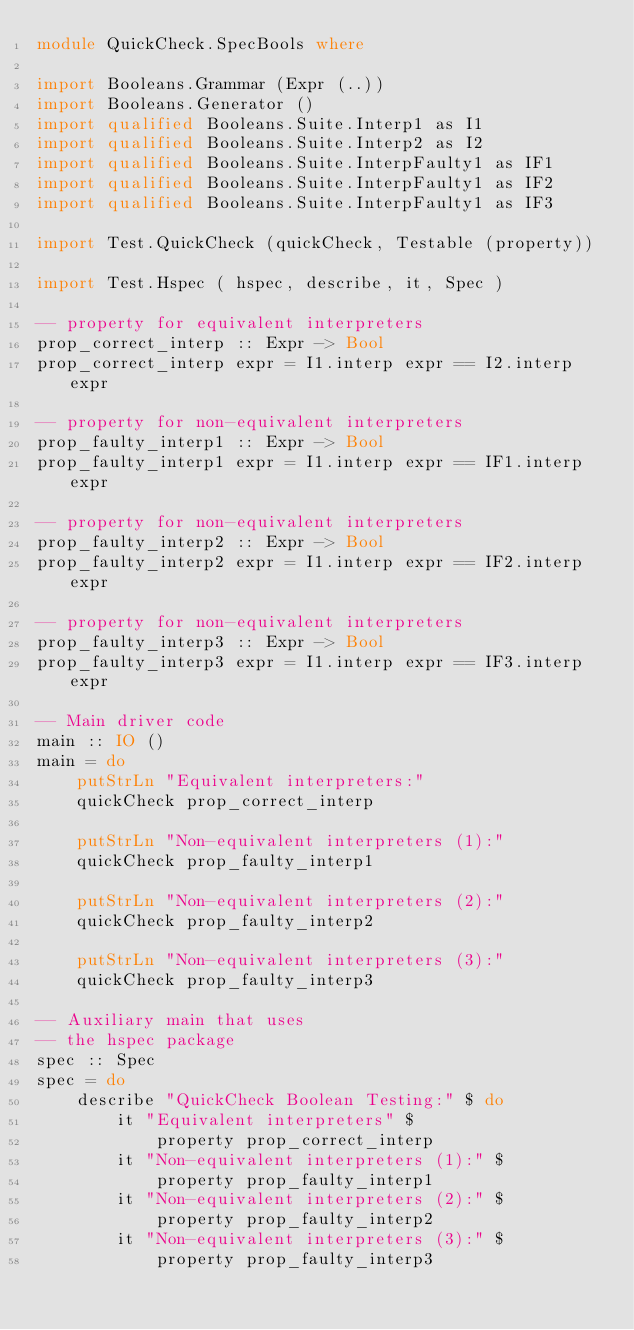<code> <loc_0><loc_0><loc_500><loc_500><_Haskell_>module QuickCheck.SpecBools where

import Booleans.Grammar (Expr (..))
import Booleans.Generator ()
import qualified Booleans.Suite.Interp1 as I1
import qualified Booleans.Suite.Interp2 as I2
import qualified Booleans.Suite.InterpFaulty1 as IF1
import qualified Booleans.Suite.InterpFaulty1 as IF2
import qualified Booleans.Suite.InterpFaulty1 as IF3

import Test.QuickCheck (quickCheck, Testable (property))

import Test.Hspec ( hspec, describe, it, Spec )

-- property for equivalent interpreters
prop_correct_interp :: Expr -> Bool 
prop_correct_interp expr = I1.interp expr == I2.interp expr

-- property for non-equivalent interpreters
prop_faulty_interp1 :: Expr -> Bool 
prop_faulty_interp1 expr = I1.interp expr == IF1.interp expr

-- property for non-equivalent interpreters
prop_faulty_interp2 :: Expr -> Bool 
prop_faulty_interp2 expr = I1.interp expr == IF2.interp expr

-- property for non-equivalent interpreters
prop_faulty_interp3 :: Expr -> Bool 
prop_faulty_interp3 expr = I1.interp expr == IF3.interp expr

-- Main driver code
main :: IO ()
main = do
    putStrLn "Equivalent interpreters:"
    quickCheck prop_correct_interp

    putStrLn "Non-equivalent interpreters (1):"
    quickCheck prop_faulty_interp1

    putStrLn "Non-equivalent interpreters (2):"
    quickCheck prop_faulty_interp2

    putStrLn "Non-equivalent interpreters (3):"
    quickCheck prop_faulty_interp3

-- Auxiliary main that uses
-- the hspec package
spec :: Spec
spec = do
    describe "QuickCheck Boolean Testing:" $ do
        it "Equivalent interpreters" $
            property prop_correct_interp
        it "Non-equivalent interpreters (1):" $
            property prop_faulty_interp1
        it "Non-equivalent interpreters (2):" $
            property prop_faulty_interp2
        it "Non-equivalent interpreters (3):" $
            property prop_faulty_interp3</code> 